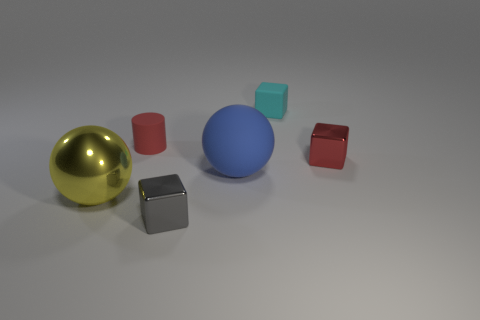Considering the lighting and shadows, what time of day or lighting conditions does the image suggest? The image does not imply a specific time of day, since it appears to be a controlled studio setting with even lighting, creating soft shadows beneath each object. This suggests an indoor photo shoot with artificial lighting rather than natural daylight. 